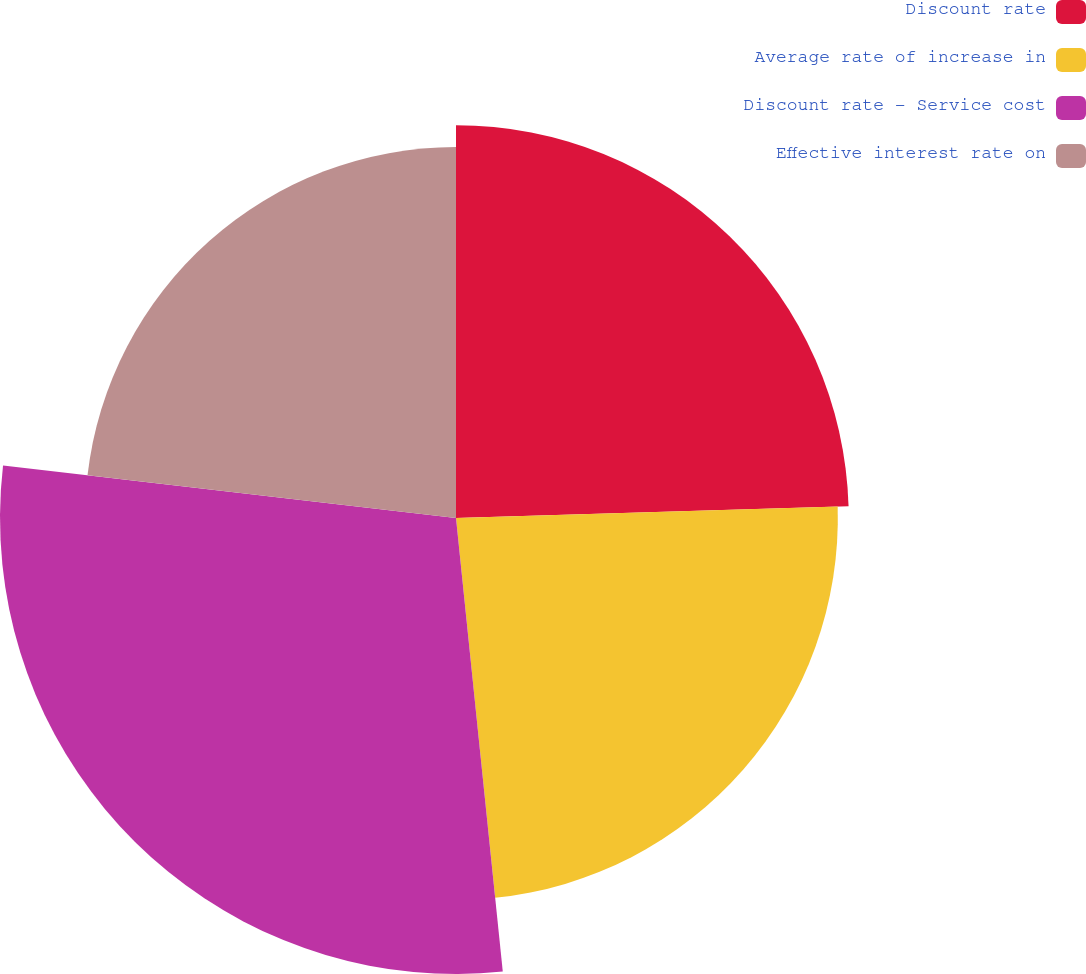Convert chart. <chart><loc_0><loc_0><loc_500><loc_500><pie_chart><fcel>Discount rate<fcel>Average rate of increase in<fcel>Discount rate - Service cost<fcel>Effective interest rate on<nl><fcel>24.52%<fcel>23.84%<fcel>28.47%<fcel>23.16%<nl></chart> 